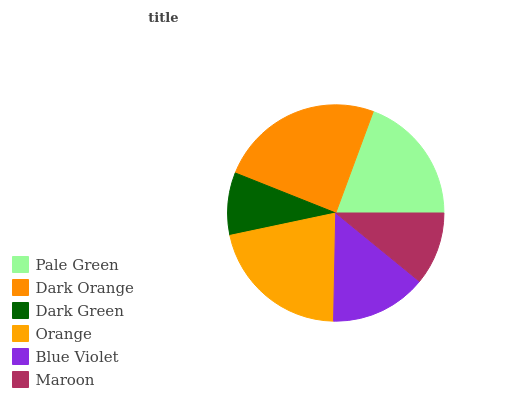Is Dark Green the minimum?
Answer yes or no. Yes. Is Dark Orange the maximum?
Answer yes or no. Yes. Is Dark Orange the minimum?
Answer yes or no. No. Is Dark Green the maximum?
Answer yes or no. No. Is Dark Orange greater than Dark Green?
Answer yes or no. Yes. Is Dark Green less than Dark Orange?
Answer yes or no. Yes. Is Dark Green greater than Dark Orange?
Answer yes or no. No. Is Dark Orange less than Dark Green?
Answer yes or no. No. Is Pale Green the high median?
Answer yes or no. Yes. Is Blue Violet the low median?
Answer yes or no. Yes. Is Orange the high median?
Answer yes or no. No. Is Dark Green the low median?
Answer yes or no. No. 